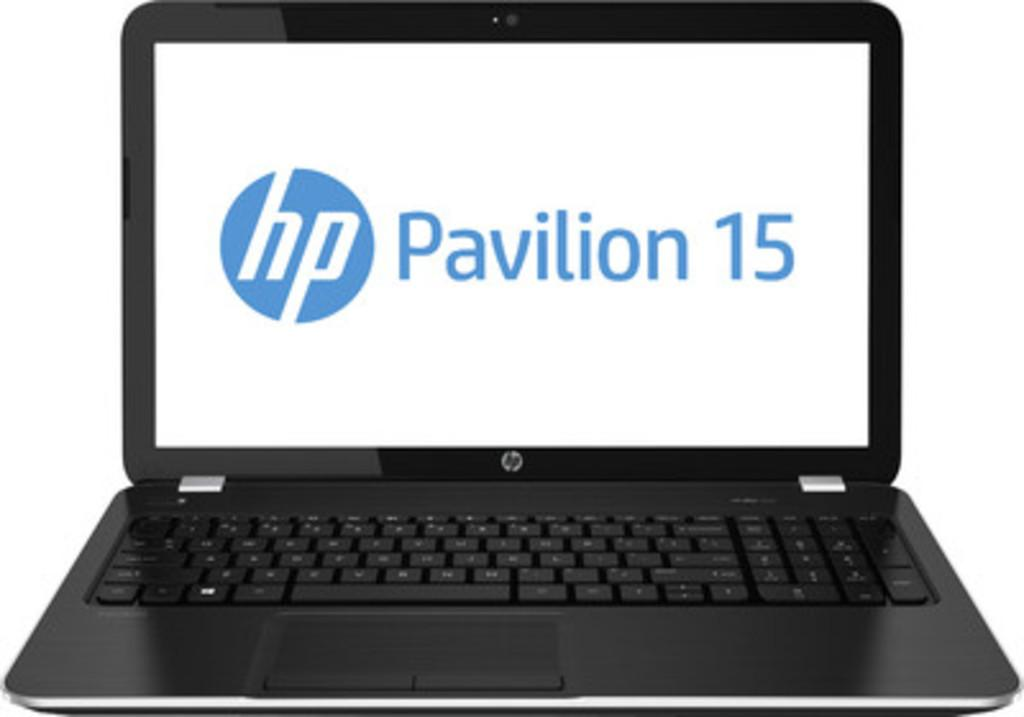<image>
Present a compact description of the photo's key features. Hp Pavilion 15 laptop in black and white in a picture 